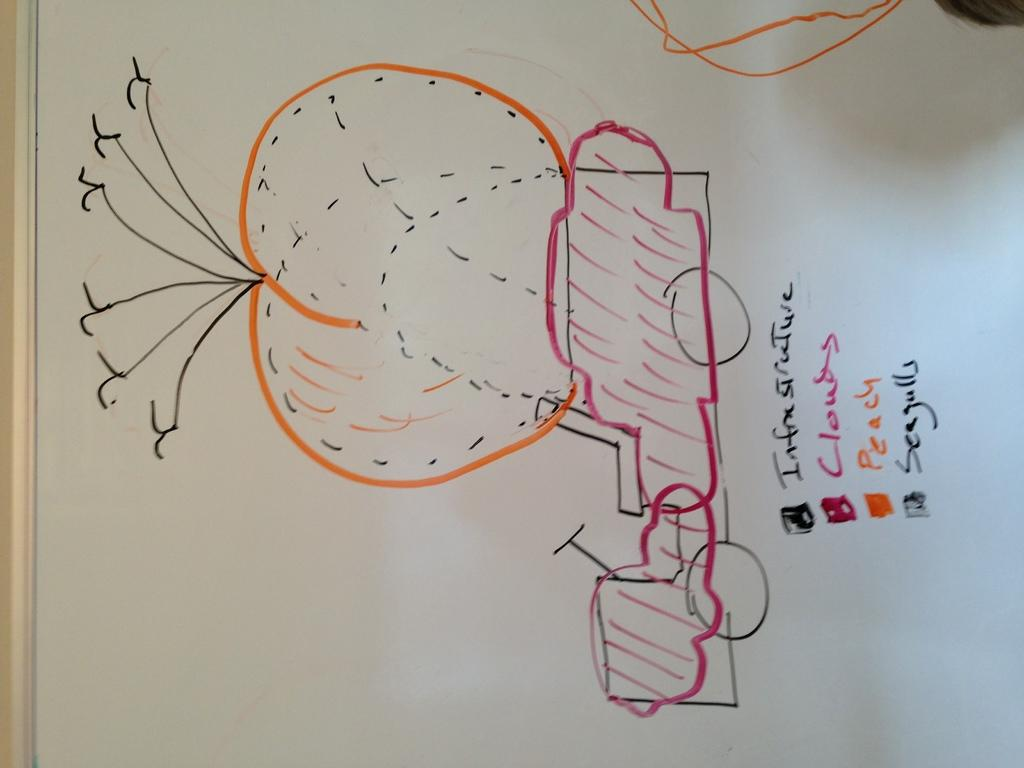<image>
Create a compact narrative representing the image presented. A drawing of a vehicle with a large peach on top of it is shown with Infrastructure, Cloud, Peach and Seagulls listed underneath it. 